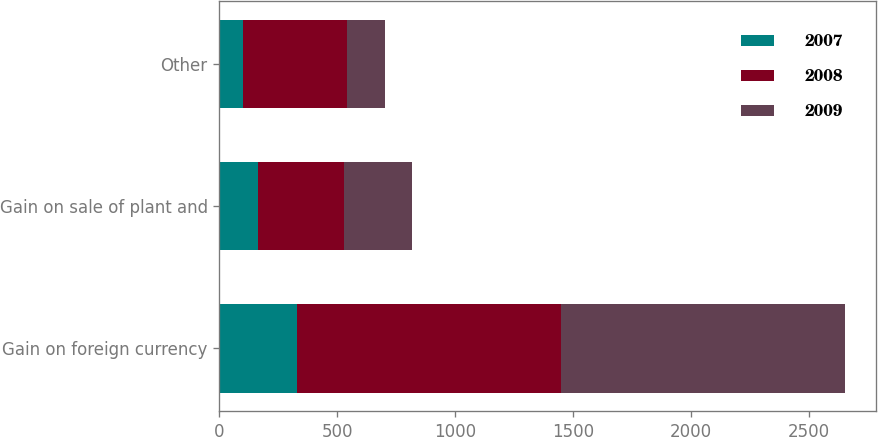Convert chart to OTSL. <chart><loc_0><loc_0><loc_500><loc_500><stacked_bar_chart><ecel><fcel>Gain on foreign currency<fcel>Gain on sale of plant and<fcel>Other<nl><fcel>2007<fcel>328<fcel>163<fcel>99<nl><fcel>2008<fcel>1121<fcel>365<fcel>444<nl><fcel>2009<fcel>1203<fcel>291<fcel>161<nl></chart> 